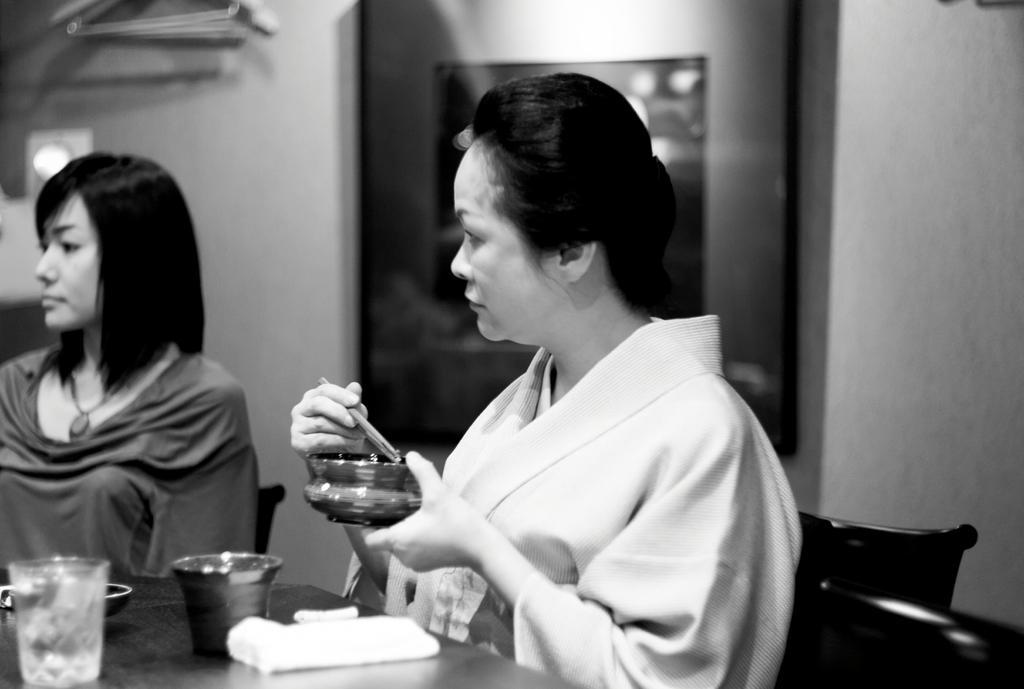Please provide a concise description of this image. In this image there are two women sitting on the chair, a woman is holding an object, there is a table towards the bottom of the image, there are objects on the table, at the background of the image there is the wall, there is a photo frame on the wall, there is a light on the wall, there is an object towards the left of the image, there is an object towards the top of the image. 